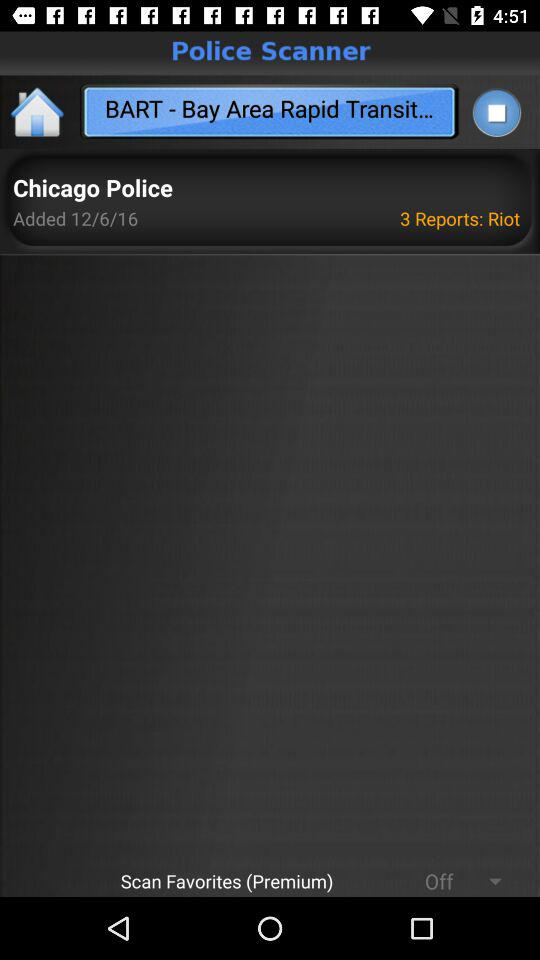What is the name of the application? The name of the application is "Police Scanner". 